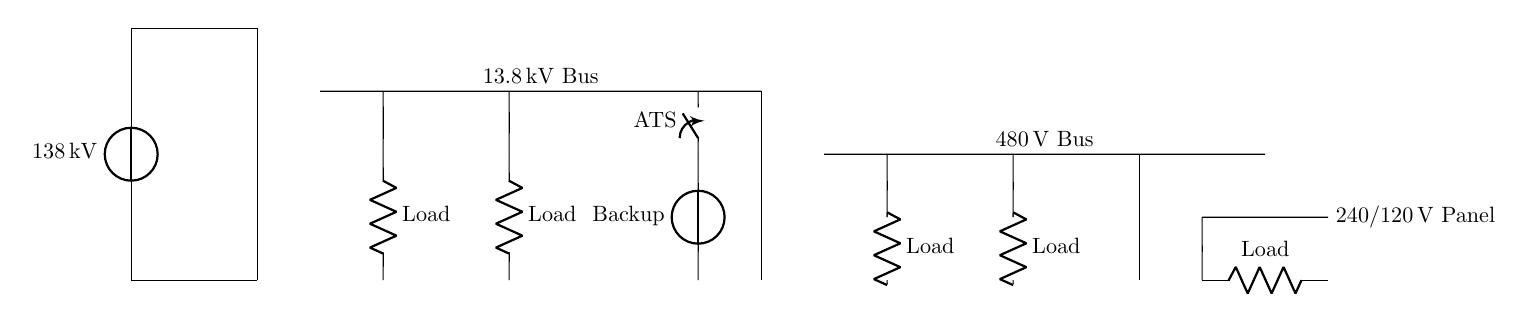What is the main voltage supply entering the facility? The main voltage supply is indicated at the start of the circuit diagram as 138 kV, which represents the input from the power source to the system.
Answer: 138 kV What type of transformer is used for stepping down the voltage? The circuit diagram shows a transformer core labeled as a step-down transformer, which indicates that it is designed to reduce the voltage from 138 kV to a lower level compatible with the bus systems.
Answer: Step-down transformer How many different voltage levels are present in the distribution system? The circuit shows three distinct voltage levels: 138 kV, 13.8 kV, and 480 V, indicating a multi-tiered distribution system throughout the facility.
Answer: Three What is the role of the ATS in this system? The ATS, or Automatic Transfer Switch, allows for the transition between the main power source and the backup generator, ensuring continuous power supply during outages or maintenance.
Answer: Power transition Which bus distributes the lowest voltage? The circuit diagram reveals that the 240/120 V panel is the final output from the transformers, indicating that it represents the distribution of the lowest voltage in the system.
Answer: 240/120 V What type of loads are shown in the circuit diagram? The loads depicted in the diagram are all resistive loads, as indicated by the symbol 'R' next to each load component, representing typical electrical components such as motors, heating elements, or lighting.
Answer: Resistive loads Where is the backup generator connected in the circuit? The backup generator is connected to the circuit through a closing switch labeled ATS, which allows for seamless operation and integration into the power distribution system when activated.
Answer: After ATS 